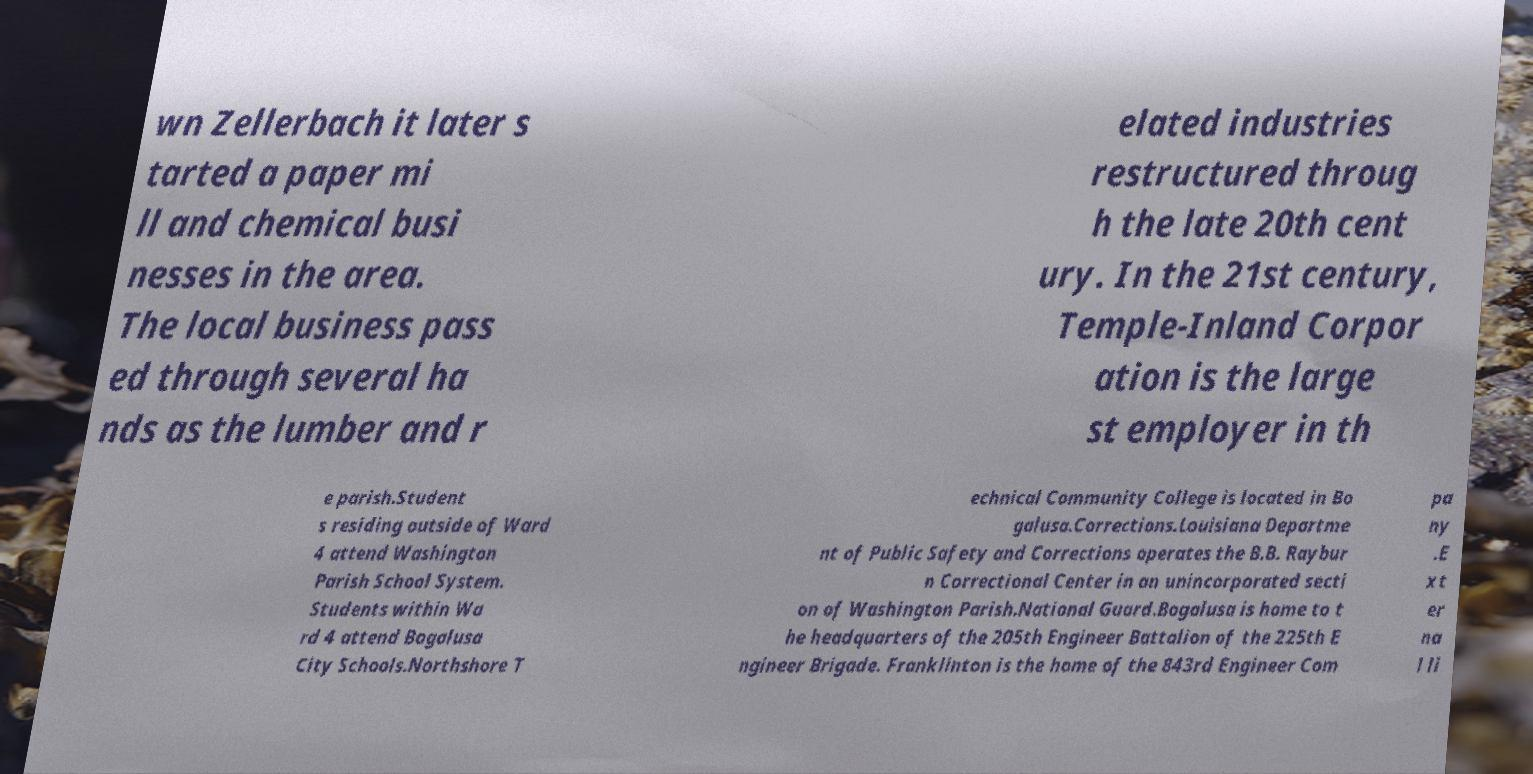For documentation purposes, I need the text within this image transcribed. Could you provide that? wn Zellerbach it later s tarted a paper mi ll and chemical busi nesses in the area. The local business pass ed through several ha nds as the lumber and r elated industries restructured throug h the late 20th cent ury. In the 21st century, Temple-Inland Corpor ation is the large st employer in th e parish.Student s residing outside of Ward 4 attend Washington Parish School System. Students within Wa rd 4 attend Bogalusa City Schools.Northshore T echnical Community College is located in Bo galusa.Corrections.Louisiana Departme nt of Public Safety and Corrections operates the B.B. Raybur n Correctional Center in an unincorporated secti on of Washington Parish.National Guard.Bogalusa is home to t he headquarters of the 205th Engineer Battalion of the 225th E ngineer Brigade. Franklinton is the home of the 843rd Engineer Com pa ny .E xt er na l li 